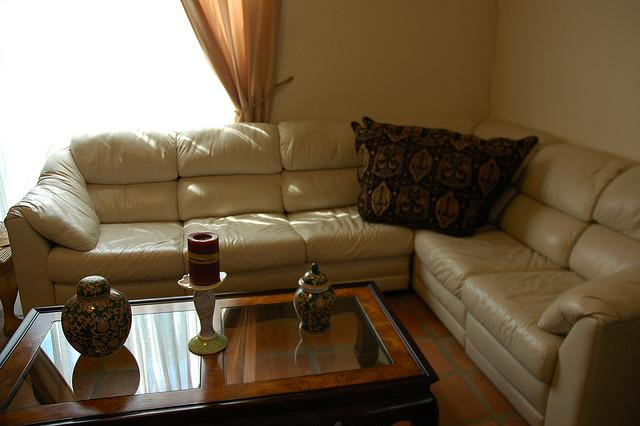Which item is most likely made from animal skin?

Choices:
A) couch
B) candle
C) floor
D) pillow couch 